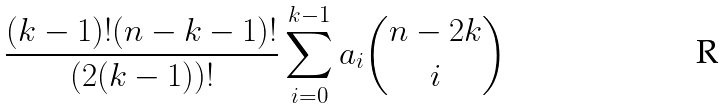Convert formula to latex. <formula><loc_0><loc_0><loc_500><loc_500>\frac { ( k - 1 ) ! ( n - k - 1 ) ! } { \left ( 2 ( k - 1 ) \right ) ! } \sum _ { i = 0 } ^ { k - 1 } a _ { i } \binom { n - 2 k } { i }</formula> 